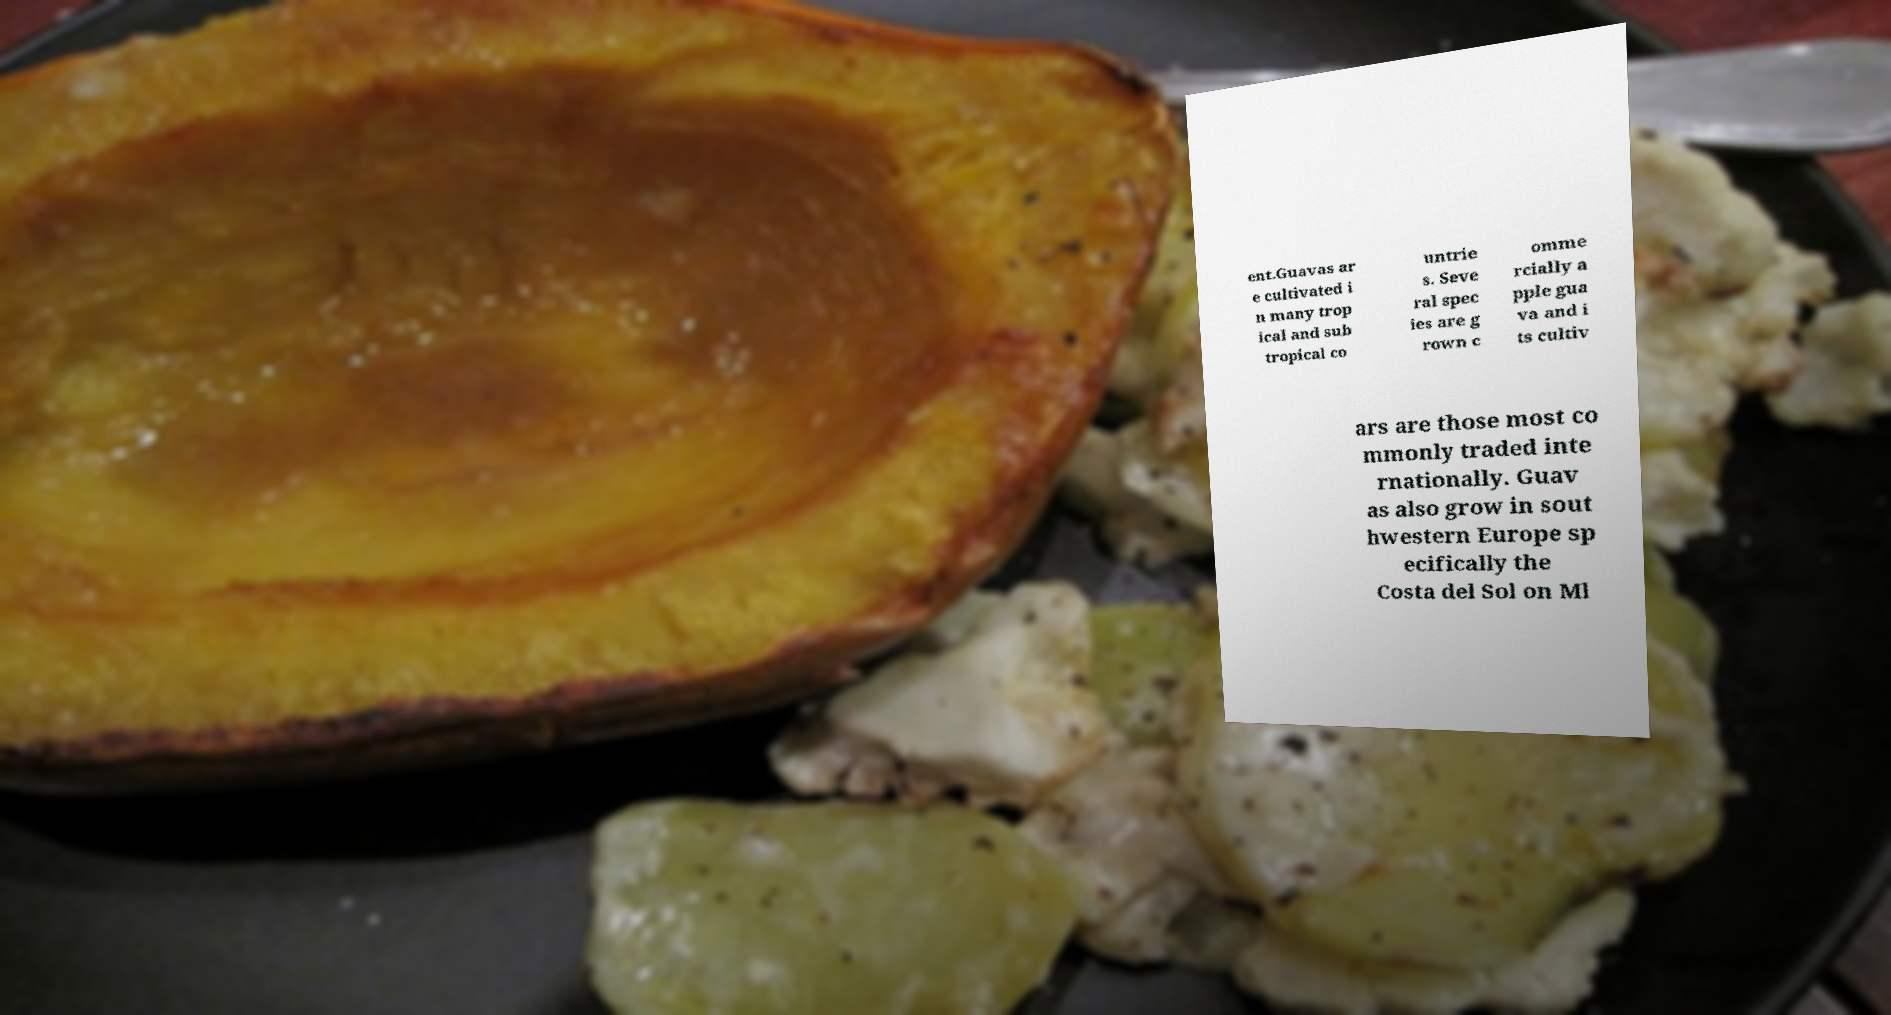Could you extract and type out the text from this image? Certainly! The text visible in the image reads: 'Guavas are cultivated in many tropical and subtropical countries. Several species are grown commercially; apple guava and its cultivars are those most commonly traded internationally. Guavas also grow in southwestern Europe, specifically the Costa del Sol on Málaga.' 